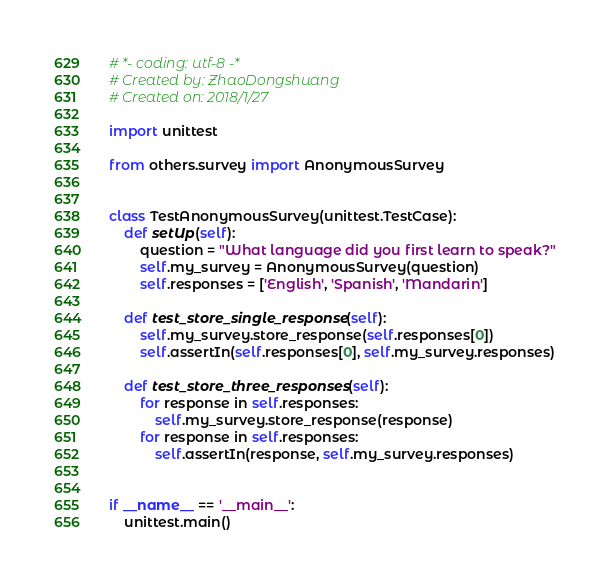Convert code to text. <code><loc_0><loc_0><loc_500><loc_500><_Python_># *- coding: utf-8 -*
# Created by: ZhaoDongshuang
# Created on: 2018/1/27

import unittest

from others.survey import AnonymousSurvey


class TestAnonymousSurvey(unittest.TestCase):
    def setUp(self):
        question = "What language did you first learn to speak?"
        self.my_survey = AnonymousSurvey(question)
        self.responses = ['English', 'Spanish', 'Mandarin']

    def test_store_single_response(self):
        self.my_survey.store_response(self.responses[0])
        self.assertIn(self.responses[0], self.my_survey.responses)

    def test_store_three_responses(self):
        for response in self.responses:
            self.my_survey.store_response(response)
        for response in self.responses:
            self.assertIn(response, self.my_survey.responses)


if __name__ == '__main__':
    unittest.main()
</code> 